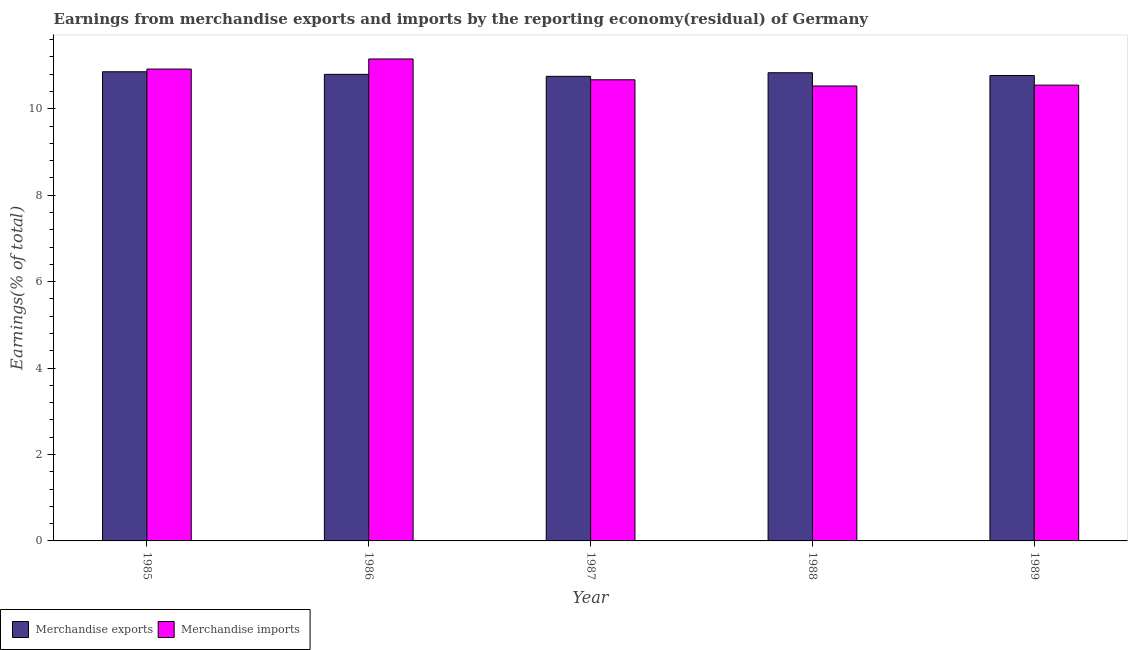How many bars are there on the 2nd tick from the right?
Provide a succinct answer. 2. What is the label of the 1st group of bars from the left?
Ensure brevity in your answer.  1985. What is the earnings from merchandise imports in 1986?
Your answer should be very brief. 11.15. Across all years, what is the maximum earnings from merchandise exports?
Your answer should be very brief. 10.86. Across all years, what is the minimum earnings from merchandise exports?
Provide a short and direct response. 10.75. In which year was the earnings from merchandise imports maximum?
Offer a terse response. 1986. What is the total earnings from merchandise imports in the graph?
Offer a very short reply. 53.81. What is the difference between the earnings from merchandise imports in 1985 and that in 1988?
Make the answer very short. 0.39. What is the difference between the earnings from merchandise imports in 1987 and the earnings from merchandise exports in 1989?
Offer a very short reply. 0.12. What is the average earnings from merchandise imports per year?
Your answer should be compact. 10.76. In the year 1988, what is the difference between the earnings from merchandise exports and earnings from merchandise imports?
Make the answer very short. 0. In how many years, is the earnings from merchandise exports greater than 2.8 %?
Offer a very short reply. 5. What is the ratio of the earnings from merchandise imports in 1988 to that in 1989?
Your response must be concise. 1. Is the earnings from merchandise exports in 1985 less than that in 1986?
Your response must be concise. No. What is the difference between the highest and the second highest earnings from merchandise imports?
Keep it short and to the point. 0.23. What is the difference between the highest and the lowest earnings from merchandise exports?
Keep it short and to the point. 0.11. Is the sum of the earnings from merchandise imports in 1985 and 1988 greater than the maximum earnings from merchandise exports across all years?
Keep it short and to the point. Yes. What does the 1st bar from the left in 1986 represents?
Your answer should be compact. Merchandise exports. How many years are there in the graph?
Ensure brevity in your answer.  5. Where does the legend appear in the graph?
Make the answer very short. Bottom left. What is the title of the graph?
Keep it short and to the point. Earnings from merchandise exports and imports by the reporting economy(residual) of Germany. Does "IMF concessional" appear as one of the legend labels in the graph?
Make the answer very short. No. What is the label or title of the Y-axis?
Offer a very short reply. Earnings(% of total). What is the Earnings(% of total) of Merchandise exports in 1985?
Ensure brevity in your answer.  10.86. What is the Earnings(% of total) in Merchandise imports in 1985?
Make the answer very short. 10.92. What is the Earnings(% of total) in Merchandise exports in 1986?
Your answer should be compact. 10.8. What is the Earnings(% of total) of Merchandise imports in 1986?
Offer a terse response. 11.15. What is the Earnings(% of total) of Merchandise exports in 1987?
Provide a succinct answer. 10.75. What is the Earnings(% of total) of Merchandise imports in 1987?
Your answer should be very brief. 10.67. What is the Earnings(% of total) of Merchandise exports in 1988?
Keep it short and to the point. 10.83. What is the Earnings(% of total) of Merchandise imports in 1988?
Make the answer very short. 10.53. What is the Earnings(% of total) in Merchandise exports in 1989?
Keep it short and to the point. 10.77. What is the Earnings(% of total) in Merchandise imports in 1989?
Provide a short and direct response. 10.55. Across all years, what is the maximum Earnings(% of total) in Merchandise exports?
Make the answer very short. 10.86. Across all years, what is the maximum Earnings(% of total) of Merchandise imports?
Keep it short and to the point. 11.15. Across all years, what is the minimum Earnings(% of total) in Merchandise exports?
Ensure brevity in your answer.  10.75. Across all years, what is the minimum Earnings(% of total) in Merchandise imports?
Offer a very short reply. 10.53. What is the total Earnings(% of total) of Merchandise exports in the graph?
Keep it short and to the point. 54. What is the total Earnings(% of total) of Merchandise imports in the graph?
Provide a short and direct response. 53.81. What is the difference between the Earnings(% of total) in Merchandise exports in 1985 and that in 1986?
Offer a very short reply. 0.06. What is the difference between the Earnings(% of total) of Merchandise imports in 1985 and that in 1986?
Provide a short and direct response. -0.23. What is the difference between the Earnings(% of total) in Merchandise exports in 1985 and that in 1987?
Provide a short and direct response. 0.11. What is the difference between the Earnings(% of total) of Merchandise imports in 1985 and that in 1987?
Keep it short and to the point. 0.25. What is the difference between the Earnings(% of total) in Merchandise exports in 1985 and that in 1988?
Offer a terse response. 0.02. What is the difference between the Earnings(% of total) of Merchandise imports in 1985 and that in 1988?
Offer a terse response. 0.39. What is the difference between the Earnings(% of total) of Merchandise exports in 1985 and that in 1989?
Offer a very short reply. 0.09. What is the difference between the Earnings(% of total) of Merchandise imports in 1985 and that in 1989?
Offer a terse response. 0.37. What is the difference between the Earnings(% of total) of Merchandise exports in 1986 and that in 1987?
Your response must be concise. 0.05. What is the difference between the Earnings(% of total) in Merchandise imports in 1986 and that in 1987?
Offer a very short reply. 0.48. What is the difference between the Earnings(% of total) of Merchandise exports in 1986 and that in 1988?
Your response must be concise. -0.04. What is the difference between the Earnings(% of total) of Merchandise imports in 1986 and that in 1988?
Give a very brief answer. 0.63. What is the difference between the Earnings(% of total) of Merchandise exports in 1986 and that in 1989?
Make the answer very short. 0.03. What is the difference between the Earnings(% of total) in Merchandise imports in 1986 and that in 1989?
Your response must be concise. 0.6. What is the difference between the Earnings(% of total) of Merchandise exports in 1987 and that in 1988?
Your answer should be compact. -0.08. What is the difference between the Earnings(% of total) in Merchandise imports in 1987 and that in 1988?
Ensure brevity in your answer.  0.14. What is the difference between the Earnings(% of total) in Merchandise exports in 1987 and that in 1989?
Provide a short and direct response. -0.02. What is the difference between the Earnings(% of total) of Merchandise imports in 1987 and that in 1989?
Provide a short and direct response. 0.12. What is the difference between the Earnings(% of total) in Merchandise exports in 1988 and that in 1989?
Your answer should be compact. 0.06. What is the difference between the Earnings(% of total) of Merchandise imports in 1988 and that in 1989?
Provide a short and direct response. -0.02. What is the difference between the Earnings(% of total) of Merchandise exports in 1985 and the Earnings(% of total) of Merchandise imports in 1986?
Your answer should be compact. -0.3. What is the difference between the Earnings(% of total) in Merchandise exports in 1985 and the Earnings(% of total) in Merchandise imports in 1987?
Offer a very short reply. 0.19. What is the difference between the Earnings(% of total) in Merchandise exports in 1985 and the Earnings(% of total) in Merchandise imports in 1988?
Provide a short and direct response. 0.33. What is the difference between the Earnings(% of total) of Merchandise exports in 1985 and the Earnings(% of total) of Merchandise imports in 1989?
Your response must be concise. 0.31. What is the difference between the Earnings(% of total) in Merchandise exports in 1986 and the Earnings(% of total) in Merchandise imports in 1987?
Provide a succinct answer. 0.13. What is the difference between the Earnings(% of total) in Merchandise exports in 1986 and the Earnings(% of total) in Merchandise imports in 1988?
Ensure brevity in your answer.  0.27. What is the difference between the Earnings(% of total) in Merchandise exports in 1986 and the Earnings(% of total) in Merchandise imports in 1989?
Your answer should be compact. 0.25. What is the difference between the Earnings(% of total) of Merchandise exports in 1987 and the Earnings(% of total) of Merchandise imports in 1988?
Offer a terse response. 0.22. What is the difference between the Earnings(% of total) of Merchandise exports in 1987 and the Earnings(% of total) of Merchandise imports in 1989?
Ensure brevity in your answer.  0.2. What is the difference between the Earnings(% of total) of Merchandise exports in 1988 and the Earnings(% of total) of Merchandise imports in 1989?
Give a very brief answer. 0.29. What is the average Earnings(% of total) in Merchandise exports per year?
Provide a succinct answer. 10.8. What is the average Earnings(% of total) of Merchandise imports per year?
Offer a terse response. 10.76. In the year 1985, what is the difference between the Earnings(% of total) of Merchandise exports and Earnings(% of total) of Merchandise imports?
Give a very brief answer. -0.06. In the year 1986, what is the difference between the Earnings(% of total) in Merchandise exports and Earnings(% of total) in Merchandise imports?
Give a very brief answer. -0.36. In the year 1987, what is the difference between the Earnings(% of total) in Merchandise exports and Earnings(% of total) in Merchandise imports?
Keep it short and to the point. 0.08. In the year 1988, what is the difference between the Earnings(% of total) in Merchandise exports and Earnings(% of total) in Merchandise imports?
Keep it short and to the point. 0.31. In the year 1989, what is the difference between the Earnings(% of total) of Merchandise exports and Earnings(% of total) of Merchandise imports?
Provide a succinct answer. 0.22. What is the ratio of the Earnings(% of total) of Merchandise exports in 1985 to that in 1986?
Provide a short and direct response. 1.01. What is the ratio of the Earnings(% of total) in Merchandise exports in 1985 to that in 1987?
Offer a very short reply. 1.01. What is the ratio of the Earnings(% of total) of Merchandise imports in 1985 to that in 1987?
Give a very brief answer. 1.02. What is the ratio of the Earnings(% of total) of Merchandise exports in 1985 to that in 1988?
Offer a terse response. 1. What is the ratio of the Earnings(% of total) of Merchandise imports in 1985 to that in 1988?
Give a very brief answer. 1.04. What is the ratio of the Earnings(% of total) of Merchandise imports in 1985 to that in 1989?
Make the answer very short. 1.04. What is the ratio of the Earnings(% of total) in Merchandise imports in 1986 to that in 1987?
Keep it short and to the point. 1.05. What is the ratio of the Earnings(% of total) in Merchandise imports in 1986 to that in 1988?
Make the answer very short. 1.06. What is the ratio of the Earnings(% of total) in Merchandise exports in 1986 to that in 1989?
Provide a succinct answer. 1. What is the ratio of the Earnings(% of total) of Merchandise imports in 1986 to that in 1989?
Ensure brevity in your answer.  1.06. What is the ratio of the Earnings(% of total) in Merchandise exports in 1987 to that in 1988?
Ensure brevity in your answer.  0.99. What is the ratio of the Earnings(% of total) of Merchandise imports in 1987 to that in 1988?
Provide a short and direct response. 1.01. What is the ratio of the Earnings(% of total) of Merchandise imports in 1987 to that in 1989?
Offer a terse response. 1.01. What is the ratio of the Earnings(% of total) in Merchandise exports in 1988 to that in 1989?
Provide a short and direct response. 1.01. What is the difference between the highest and the second highest Earnings(% of total) in Merchandise exports?
Offer a terse response. 0.02. What is the difference between the highest and the second highest Earnings(% of total) in Merchandise imports?
Your answer should be compact. 0.23. What is the difference between the highest and the lowest Earnings(% of total) in Merchandise exports?
Your answer should be very brief. 0.11. What is the difference between the highest and the lowest Earnings(% of total) in Merchandise imports?
Keep it short and to the point. 0.63. 